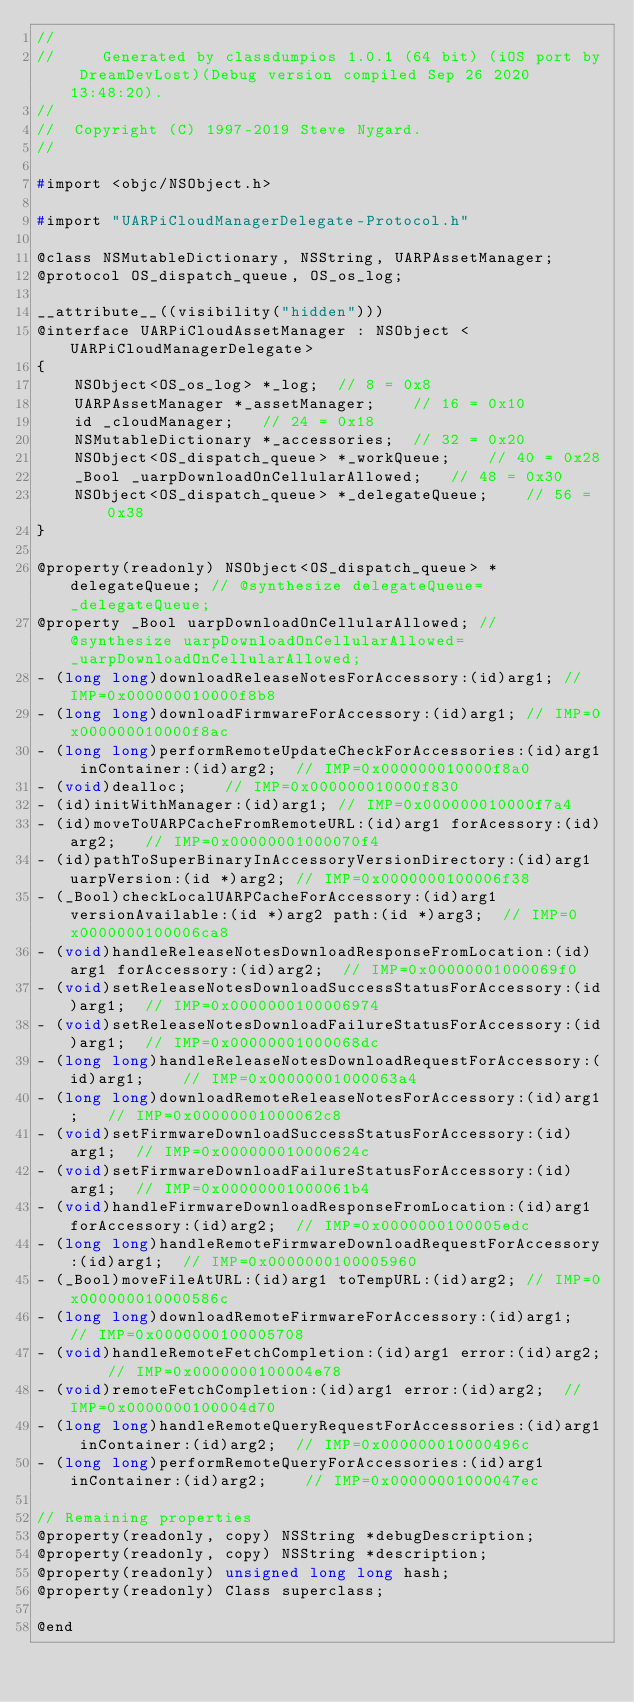Convert code to text. <code><loc_0><loc_0><loc_500><loc_500><_C_>//
//     Generated by classdumpios 1.0.1 (64 bit) (iOS port by DreamDevLost)(Debug version compiled Sep 26 2020 13:48:20).
//
//  Copyright (C) 1997-2019 Steve Nygard.
//

#import <objc/NSObject.h>

#import "UARPiCloudManagerDelegate-Protocol.h"

@class NSMutableDictionary, NSString, UARPAssetManager;
@protocol OS_dispatch_queue, OS_os_log;

__attribute__((visibility("hidden")))
@interface UARPiCloudAssetManager : NSObject <UARPiCloudManagerDelegate>
{
    NSObject<OS_os_log> *_log;	// 8 = 0x8
    UARPAssetManager *_assetManager;	// 16 = 0x10
    id _cloudManager;	// 24 = 0x18
    NSMutableDictionary *_accessories;	// 32 = 0x20
    NSObject<OS_dispatch_queue> *_workQueue;	// 40 = 0x28
    _Bool _uarpDownloadOnCellularAllowed;	// 48 = 0x30
    NSObject<OS_dispatch_queue> *_delegateQueue;	// 56 = 0x38
}

@property(readonly) NSObject<OS_dispatch_queue> *delegateQueue; // @synthesize delegateQueue=_delegateQueue;
@property _Bool uarpDownloadOnCellularAllowed; // @synthesize uarpDownloadOnCellularAllowed=_uarpDownloadOnCellularAllowed;
- (long long)downloadReleaseNotesForAccessory:(id)arg1;	// IMP=0x000000010000f8b8
- (long long)downloadFirmwareForAccessory:(id)arg1;	// IMP=0x000000010000f8ac
- (long long)performRemoteUpdateCheckForAccessories:(id)arg1 inContainer:(id)arg2;	// IMP=0x000000010000f8a0
- (void)dealloc;	// IMP=0x000000010000f830
- (id)initWithManager:(id)arg1;	// IMP=0x000000010000f7a4
- (id)moveToUARPCacheFromRemoteURL:(id)arg1 forAcessory:(id)arg2;	// IMP=0x00000001000070f4
- (id)pathToSuperBinaryInAccessoryVersionDirectory:(id)arg1 uarpVersion:(id *)arg2;	// IMP=0x0000000100006f38
- (_Bool)checkLocalUARPCacheForAccessory:(id)arg1 versionAvailable:(id *)arg2 path:(id *)arg3;	// IMP=0x0000000100006ca8
- (void)handleReleaseNotesDownloadResponseFromLocation:(id)arg1 forAccessory:(id)arg2;	// IMP=0x00000001000069f0
- (void)setReleaseNotesDownloadSuccessStatusForAccessory:(id)arg1;	// IMP=0x0000000100006974
- (void)setReleaseNotesDownloadFailureStatusForAccessory:(id)arg1;	// IMP=0x00000001000068dc
- (long long)handleReleaseNotesDownloadRequestForAccessory:(id)arg1;	// IMP=0x00000001000063a4
- (long long)downloadRemoteReleaseNotesForAccessory:(id)arg1;	// IMP=0x00000001000062c8
- (void)setFirmwareDownloadSuccessStatusForAccessory:(id)arg1;	// IMP=0x000000010000624c
- (void)setFirmwareDownloadFailureStatusForAccessory:(id)arg1;	// IMP=0x00000001000061b4
- (void)handleFirmwareDownloadResponseFromLocation:(id)arg1 forAccessory:(id)arg2;	// IMP=0x0000000100005edc
- (long long)handleRemoteFirmwareDownloadRequestForAccessory:(id)arg1;	// IMP=0x0000000100005960
- (_Bool)moveFileAtURL:(id)arg1 toTempURL:(id)arg2;	// IMP=0x000000010000586c
- (long long)downloadRemoteFirmwareForAccessory:(id)arg1;	// IMP=0x0000000100005708
- (void)handleRemoteFetchCompletion:(id)arg1 error:(id)arg2;	// IMP=0x0000000100004e78
- (void)remoteFetchCompletion:(id)arg1 error:(id)arg2;	// IMP=0x0000000100004d70
- (long long)handleRemoteQueryRequestForAccessories:(id)arg1 inContainer:(id)arg2;	// IMP=0x000000010000496c
- (long long)performRemoteQueryForAccessories:(id)arg1 inContainer:(id)arg2;	// IMP=0x00000001000047ec

// Remaining properties
@property(readonly, copy) NSString *debugDescription;
@property(readonly, copy) NSString *description;
@property(readonly) unsigned long long hash;
@property(readonly) Class superclass;

@end

</code> 